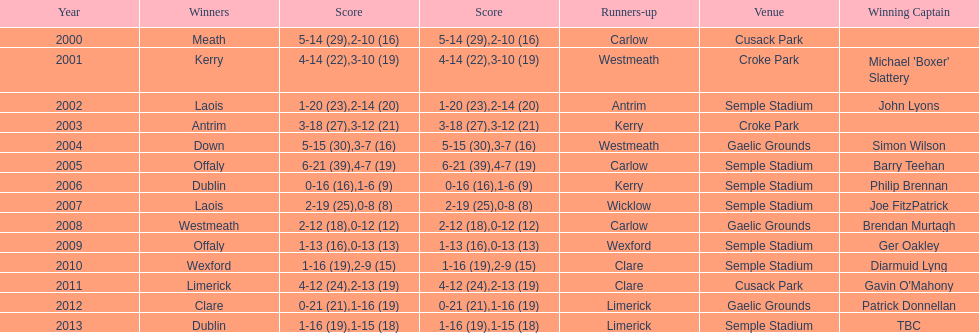How many winners won in semple stadium? 7. 